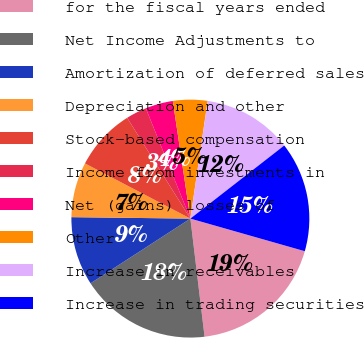<chart> <loc_0><loc_0><loc_500><loc_500><pie_chart><fcel>for the fiscal years ended<fcel>Net Income Adjustments to<fcel>Amortization of deferred sales<fcel>Depreciation and other<fcel>Stock-based compensation<fcel>Income from investments in<fcel>Net (gains) losses of<fcel>Other<fcel>Increase in receivables<fcel>Increase in trading securities<nl><fcel>18.68%<fcel>17.75%<fcel>9.35%<fcel>7.48%<fcel>8.41%<fcel>2.81%<fcel>3.75%<fcel>4.68%<fcel>12.15%<fcel>14.95%<nl></chart> 